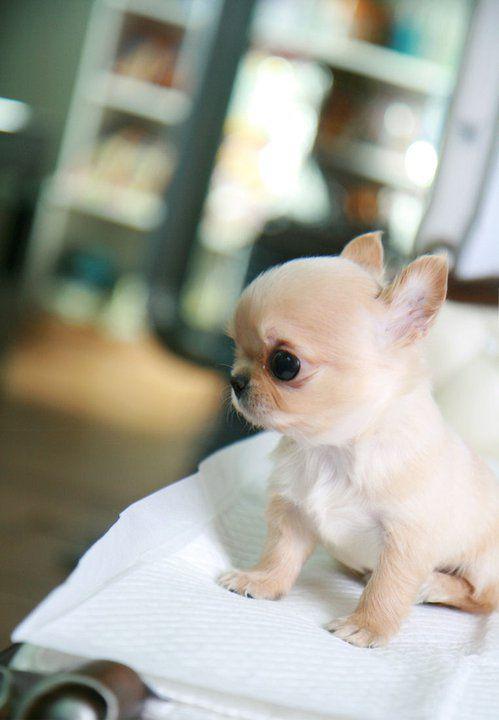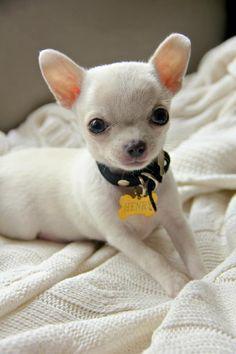The first image is the image on the left, the second image is the image on the right. Analyze the images presented: Is the assertion "There are two puppies and at least one of them is not looking at the camera." valid? Answer yes or no. Yes. The first image is the image on the left, the second image is the image on the right. Assess this claim about the two images: "puppies are propped up with a fully visible human hand". Correct or not? Answer yes or no. No. 